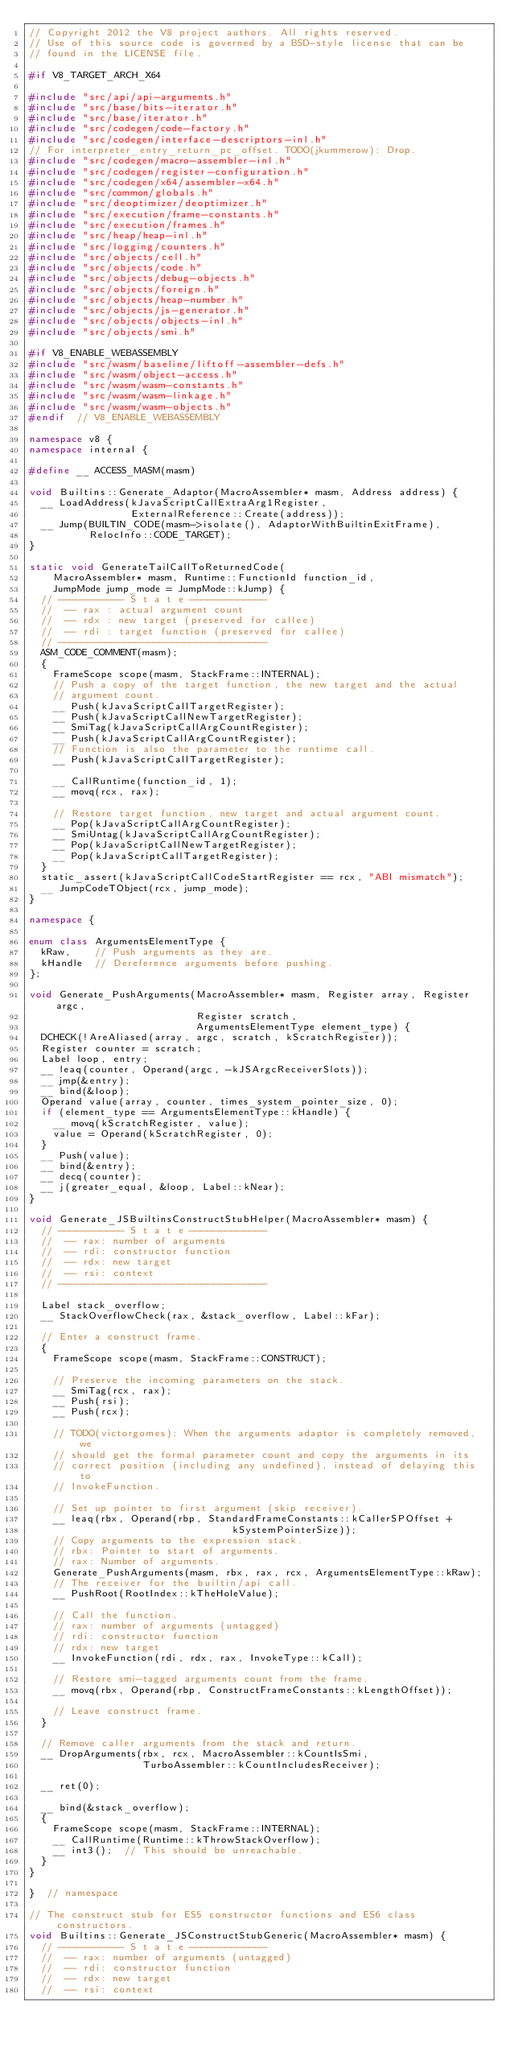<code> <loc_0><loc_0><loc_500><loc_500><_C++_>// Copyright 2012 the V8 project authors. All rights reserved.
// Use of this source code is governed by a BSD-style license that can be
// found in the LICENSE file.

#if V8_TARGET_ARCH_X64

#include "src/api/api-arguments.h"
#include "src/base/bits-iterator.h"
#include "src/base/iterator.h"
#include "src/codegen/code-factory.h"
#include "src/codegen/interface-descriptors-inl.h"
// For interpreter_entry_return_pc_offset. TODO(jkummerow): Drop.
#include "src/codegen/macro-assembler-inl.h"
#include "src/codegen/register-configuration.h"
#include "src/codegen/x64/assembler-x64.h"
#include "src/common/globals.h"
#include "src/deoptimizer/deoptimizer.h"
#include "src/execution/frame-constants.h"
#include "src/execution/frames.h"
#include "src/heap/heap-inl.h"
#include "src/logging/counters.h"
#include "src/objects/cell.h"
#include "src/objects/code.h"
#include "src/objects/debug-objects.h"
#include "src/objects/foreign.h"
#include "src/objects/heap-number.h"
#include "src/objects/js-generator.h"
#include "src/objects/objects-inl.h"
#include "src/objects/smi.h"

#if V8_ENABLE_WEBASSEMBLY
#include "src/wasm/baseline/liftoff-assembler-defs.h"
#include "src/wasm/object-access.h"
#include "src/wasm/wasm-constants.h"
#include "src/wasm/wasm-linkage.h"
#include "src/wasm/wasm-objects.h"
#endif  // V8_ENABLE_WEBASSEMBLY

namespace v8 {
namespace internal {

#define __ ACCESS_MASM(masm)

void Builtins::Generate_Adaptor(MacroAssembler* masm, Address address) {
  __ LoadAddress(kJavaScriptCallExtraArg1Register,
                 ExternalReference::Create(address));
  __ Jump(BUILTIN_CODE(masm->isolate(), AdaptorWithBuiltinExitFrame),
          RelocInfo::CODE_TARGET);
}

static void GenerateTailCallToReturnedCode(
    MacroAssembler* masm, Runtime::FunctionId function_id,
    JumpMode jump_mode = JumpMode::kJump) {
  // ----------- S t a t e -------------
  //  -- rax : actual argument count
  //  -- rdx : new target (preserved for callee)
  //  -- rdi : target function (preserved for callee)
  // -----------------------------------
  ASM_CODE_COMMENT(masm);
  {
    FrameScope scope(masm, StackFrame::INTERNAL);
    // Push a copy of the target function, the new target and the actual
    // argument count.
    __ Push(kJavaScriptCallTargetRegister);
    __ Push(kJavaScriptCallNewTargetRegister);
    __ SmiTag(kJavaScriptCallArgCountRegister);
    __ Push(kJavaScriptCallArgCountRegister);
    // Function is also the parameter to the runtime call.
    __ Push(kJavaScriptCallTargetRegister);

    __ CallRuntime(function_id, 1);
    __ movq(rcx, rax);

    // Restore target function, new target and actual argument count.
    __ Pop(kJavaScriptCallArgCountRegister);
    __ SmiUntag(kJavaScriptCallArgCountRegister);
    __ Pop(kJavaScriptCallNewTargetRegister);
    __ Pop(kJavaScriptCallTargetRegister);
  }
  static_assert(kJavaScriptCallCodeStartRegister == rcx, "ABI mismatch");
  __ JumpCodeTObject(rcx, jump_mode);
}

namespace {

enum class ArgumentsElementType {
  kRaw,    // Push arguments as they are.
  kHandle  // Dereference arguments before pushing.
};

void Generate_PushArguments(MacroAssembler* masm, Register array, Register argc,
                            Register scratch,
                            ArgumentsElementType element_type) {
  DCHECK(!AreAliased(array, argc, scratch, kScratchRegister));
  Register counter = scratch;
  Label loop, entry;
  __ leaq(counter, Operand(argc, -kJSArgcReceiverSlots));
  __ jmp(&entry);
  __ bind(&loop);
  Operand value(array, counter, times_system_pointer_size, 0);
  if (element_type == ArgumentsElementType::kHandle) {
    __ movq(kScratchRegister, value);
    value = Operand(kScratchRegister, 0);
  }
  __ Push(value);
  __ bind(&entry);
  __ decq(counter);
  __ j(greater_equal, &loop, Label::kNear);
}

void Generate_JSBuiltinsConstructStubHelper(MacroAssembler* masm) {
  // ----------- S t a t e -------------
  //  -- rax: number of arguments
  //  -- rdi: constructor function
  //  -- rdx: new target
  //  -- rsi: context
  // -----------------------------------

  Label stack_overflow;
  __ StackOverflowCheck(rax, &stack_overflow, Label::kFar);

  // Enter a construct frame.
  {
    FrameScope scope(masm, StackFrame::CONSTRUCT);

    // Preserve the incoming parameters on the stack.
    __ SmiTag(rcx, rax);
    __ Push(rsi);
    __ Push(rcx);

    // TODO(victorgomes): When the arguments adaptor is completely removed, we
    // should get the formal parameter count and copy the arguments in its
    // correct position (including any undefined), instead of delaying this to
    // InvokeFunction.

    // Set up pointer to first argument (skip receiver).
    __ leaq(rbx, Operand(rbp, StandardFrameConstants::kCallerSPOffset +
                                  kSystemPointerSize));
    // Copy arguments to the expression stack.
    // rbx: Pointer to start of arguments.
    // rax: Number of arguments.
    Generate_PushArguments(masm, rbx, rax, rcx, ArgumentsElementType::kRaw);
    // The receiver for the builtin/api call.
    __ PushRoot(RootIndex::kTheHoleValue);

    // Call the function.
    // rax: number of arguments (untagged)
    // rdi: constructor function
    // rdx: new target
    __ InvokeFunction(rdi, rdx, rax, InvokeType::kCall);

    // Restore smi-tagged arguments count from the frame.
    __ movq(rbx, Operand(rbp, ConstructFrameConstants::kLengthOffset));

    // Leave construct frame.
  }

  // Remove caller arguments from the stack and return.
  __ DropArguments(rbx, rcx, MacroAssembler::kCountIsSmi,
                   TurboAssembler::kCountIncludesReceiver);

  __ ret(0);

  __ bind(&stack_overflow);
  {
    FrameScope scope(masm, StackFrame::INTERNAL);
    __ CallRuntime(Runtime::kThrowStackOverflow);
    __ int3();  // This should be unreachable.
  }
}

}  // namespace

// The construct stub for ES5 constructor functions and ES6 class constructors.
void Builtins::Generate_JSConstructStubGeneric(MacroAssembler* masm) {
  // ----------- S t a t e -------------
  //  -- rax: number of arguments (untagged)
  //  -- rdi: constructor function
  //  -- rdx: new target
  //  -- rsi: context</code> 